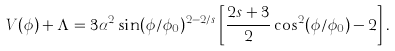<formula> <loc_0><loc_0><loc_500><loc_500>V ( \phi ) + \Lambda = 3 \alpha ^ { 2 } \sin ( \phi / \phi _ { 0 } ) ^ { 2 - 2 / s } \left [ \frac { 2 s + 3 } { 2 } \cos ^ { 2 } ( \phi / \phi _ { 0 } ) - 2 \right ] .</formula> 